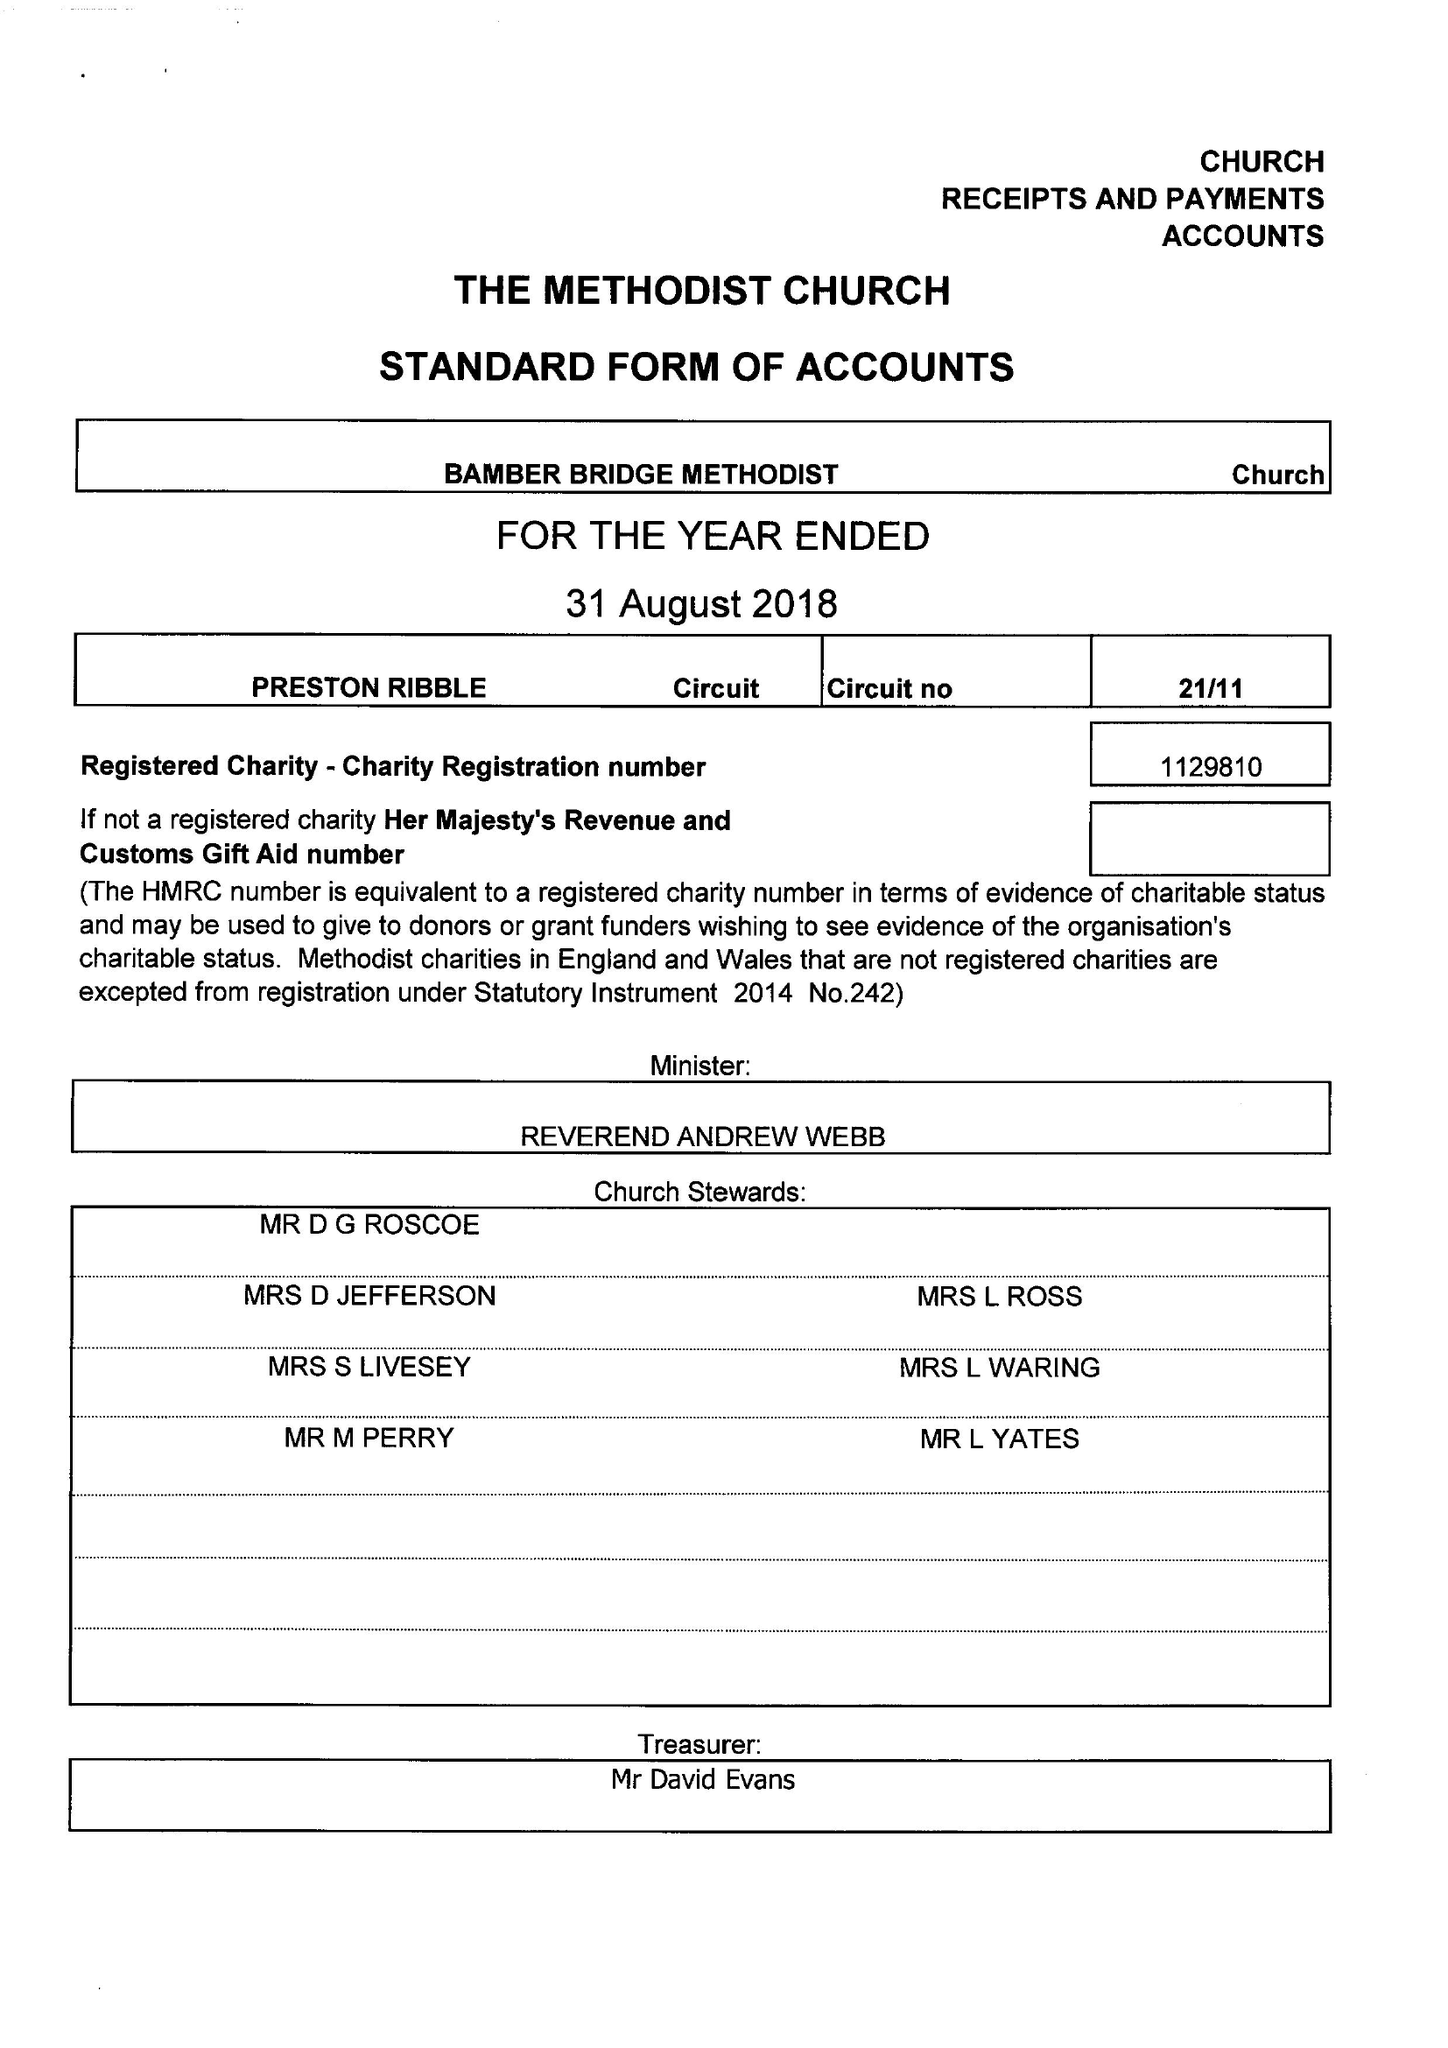What is the value for the address__post_town?
Answer the question using a single word or phrase. PRESTON 